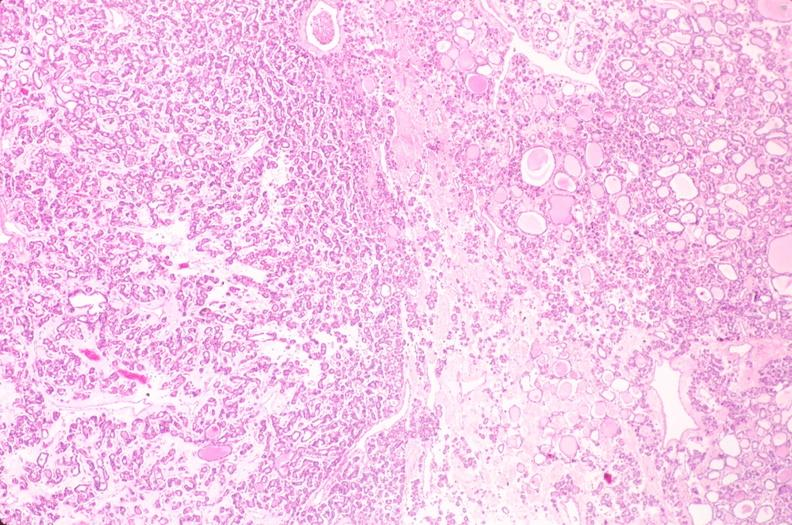s typical tuberculous exudate present?
Answer the question using a single word or phrase. No 